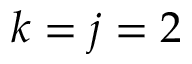Convert formula to latex. <formula><loc_0><loc_0><loc_500><loc_500>k = j = 2</formula> 